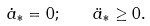Convert formula to latex. <formula><loc_0><loc_0><loc_500><loc_500>\dot { a } _ { * } = 0 ; \quad \ddot { a } _ { * } \geq 0 .</formula> 